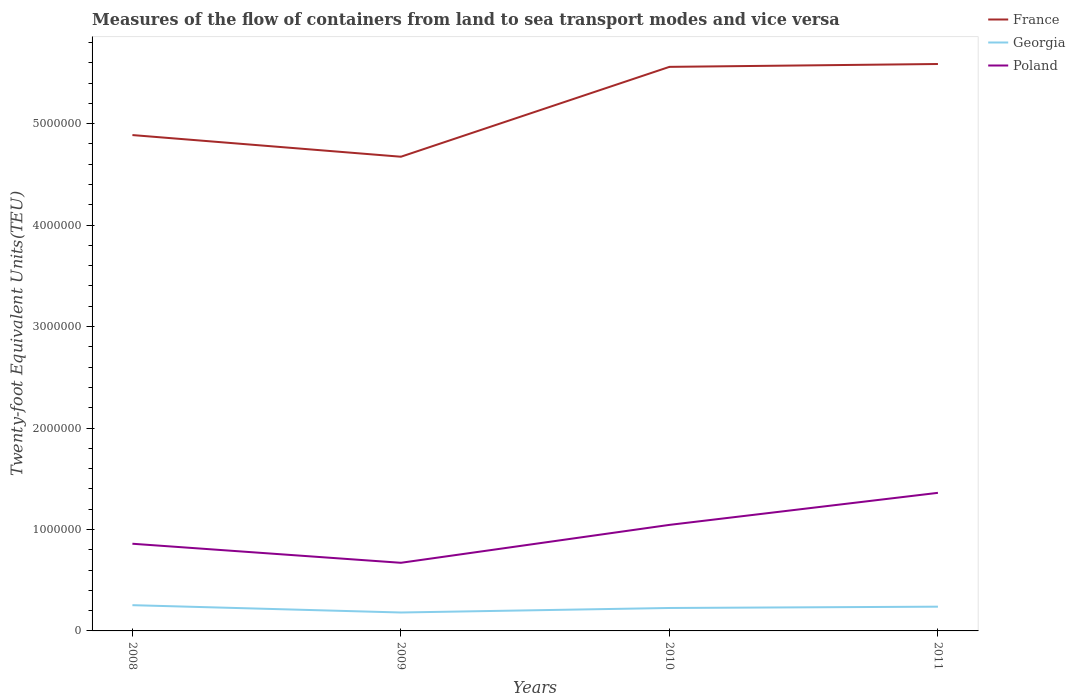How many different coloured lines are there?
Offer a terse response. 3. Does the line corresponding to Georgia intersect with the line corresponding to Poland?
Provide a succinct answer. No. Across all years, what is the maximum container port traffic in France?
Offer a terse response. 4.67e+06. What is the total container port traffic in Georgia in the graph?
Offer a very short reply. -1.29e+04. What is the difference between the highest and the second highest container port traffic in Georgia?
Ensure brevity in your answer.  7.22e+04. What is the difference between the highest and the lowest container port traffic in Georgia?
Your answer should be very brief. 3. Is the container port traffic in France strictly greater than the container port traffic in Poland over the years?
Offer a terse response. No. Does the graph contain grids?
Your response must be concise. No. How are the legend labels stacked?
Provide a succinct answer. Vertical. What is the title of the graph?
Offer a terse response. Measures of the flow of containers from land to sea transport modes and vice versa. Does "Luxembourg" appear as one of the legend labels in the graph?
Offer a terse response. No. What is the label or title of the X-axis?
Give a very brief answer. Years. What is the label or title of the Y-axis?
Your response must be concise. Twenty-foot Equivalent Units(TEU). What is the Twenty-foot Equivalent Units(TEU) of France in 2008?
Provide a succinct answer. 4.89e+06. What is the Twenty-foot Equivalent Units(TEU) of Georgia in 2008?
Provide a succinct answer. 2.54e+05. What is the Twenty-foot Equivalent Units(TEU) in Poland in 2008?
Give a very brief answer. 8.59e+05. What is the Twenty-foot Equivalent Units(TEU) in France in 2009?
Make the answer very short. 4.67e+06. What is the Twenty-foot Equivalent Units(TEU) of Georgia in 2009?
Offer a terse response. 1.82e+05. What is the Twenty-foot Equivalent Units(TEU) in Poland in 2009?
Keep it short and to the point. 6.72e+05. What is the Twenty-foot Equivalent Units(TEU) of France in 2010?
Your answer should be compact. 5.56e+06. What is the Twenty-foot Equivalent Units(TEU) in Georgia in 2010?
Provide a succinct answer. 2.26e+05. What is the Twenty-foot Equivalent Units(TEU) of Poland in 2010?
Offer a terse response. 1.05e+06. What is the Twenty-foot Equivalent Units(TEU) of France in 2011?
Make the answer very short. 5.59e+06. What is the Twenty-foot Equivalent Units(TEU) of Georgia in 2011?
Your answer should be very brief. 2.39e+05. What is the Twenty-foot Equivalent Units(TEU) in Poland in 2011?
Your answer should be very brief. 1.36e+06. Across all years, what is the maximum Twenty-foot Equivalent Units(TEU) of France?
Offer a very short reply. 5.59e+06. Across all years, what is the maximum Twenty-foot Equivalent Units(TEU) of Georgia?
Offer a terse response. 2.54e+05. Across all years, what is the maximum Twenty-foot Equivalent Units(TEU) in Poland?
Offer a very short reply. 1.36e+06. Across all years, what is the minimum Twenty-foot Equivalent Units(TEU) of France?
Provide a succinct answer. 4.67e+06. Across all years, what is the minimum Twenty-foot Equivalent Units(TEU) in Georgia?
Make the answer very short. 1.82e+05. Across all years, what is the minimum Twenty-foot Equivalent Units(TEU) of Poland?
Give a very brief answer. 6.72e+05. What is the total Twenty-foot Equivalent Units(TEU) in France in the graph?
Provide a short and direct response. 2.07e+07. What is the total Twenty-foot Equivalent Units(TEU) of Georgia in the graph?
Provide a succinct answer. 9.01e+05. What is the total Twenty-foot Equivalent Units(TEU) of Poland in the graph?
Offer a very short reply. 3.94e+06. What is the difference between the Twenty-foot Equivalent Units(TEU) of France in 2008 and that in 2009?
Ensure brevity in your answer.  2.14e+05. What is the difference between the Twenty-foot Equivalent Units(TEU) in Georgia in 2008 and that in 2009?
Your answer should be compact. 7.22e+04. What is the difference between the Twenty-foot Equivalent Units(TEU) in Poland in 2008 and that in 2009?
Ensure brevity in your answer.  1.88e+05. What is the difference between the Twenty-foot Equivalent Units(TEU) in France in 2008 and that in 2010?
Ensure brevity in your answer.  -6.72e+05. What is the difference between the Twenty-foot Equivalent Units(TEU) of Georgia in 2008 and that in 2010?
Offer a very short reply. 2.77e+04. What is the difference between the Twenty-foot Equivalent Units(TEU) in Poland in 2008 and that in 2010?
Offer a terse response. -1.86e+05. What is the difference between the Twenty-foot Equivalent Units(TEU) in France in 2008 and that in 2011?
Provide a succinct answer. -7.01e+05. What is the difference between the Twenty-foot Equivalent Units(TEU) of Georgia in 2008 and that in 2011?
Offer a terse response. 1.48e+04. What is the difference between the Twenty-foot Equivalent Units(TEU) of Poland in 2008 and that in 2011?
Make the answer very short. -5.02e+05. What is the difference between the Twenty-foot Equivalent Units(TEU) in France in 2009 and that in 2010?
Give a very brief answer. -8.86e+05. What is the difference between the Twenty-foot Equivalent Units(TEU) of Georgia in 2009 and that in 2010?
Provide a succinct answer. -4.45e+04. What is the difference between the Twenty-foot Equivalent Units(TEU) of Poland in 2009 and that in 2010?
Your answer should be compact. -3.74e+05. What is the difference between the Twenty-foot Equivalent Units(TEU) in France in 2009 and that in 2011?
Give a very brief answer. -9.14e+05. What is the difference between the Twenty-foot Equivalent Units(TEU) of Georgia in 2009 and that in 2011?
Keep it short and to the point. -5.74e+04. What is the difference between the Twenty-foot Equivalent Units(TEU) of Poland in 2009 and that in 2011?
Offer a terse response. -6.90e+05. What is the difference between the Twenty-foot Equivalent Units(TEU) of France in 2010 and that in 2011?
Give a very brief answer. -2.83e+04. What is the difference between the Twenty-foot Equivalent Units(TEU) of Georgia in 2010 and that in 2011?
Offer a terse response. -1.29e+04. What is the difference between the Twenty-foot Equivalent Units(TEU) of Poland in 2010 and that in 2011?
Ensure brevity in your answer.  -3.16e+05. What is the difference between the Twenty-foot Equivalent Units(TEU) in France in 2008 and the Twenty-foot Equivalent Units(TEU) in Georgia in 2009?
Offer a terse response. 4.71e+06. What is the difference between the Twenty-foot Equivalent Units(TEU) of France in 2008 and the Twenty-foot Equivalent Units(TEU) of Poland in 2009?
Provide a short and direct response. 4.22e+06. What is the difference between the Twenty-foot Equivalent Units(TEU) in Georgia in 2008 and the Twenty-foot Equivalent Units(TEU) in Poland in 2009?
Your response must be concise. -4.18e+05. What is the difference between the Twenty-foot Equivalent Units(TEU) of France in 2008 and the Twenty-foot Equivalent Units(TEU) of Georgia in 2010?
Ensure brevity in your answer.  4.66e+06. What is the difference between the Twenty-foot Equivalent Units(TEU) in France in 2008 and the Twenty-foot Equivalent Units(TEU) in Poland in 2010?
Make the answer very short. 3.84e+06. What is the difference between the Twenty-foot Equivalent Units(TEU) of Georgia in 2008 and the Twenty-foot Equivalent Units(TEU) of Poland in 2010?
Provide a short and direct response. -7.91e+05. What is the difference between the Twenty-foot Equivalent Units(TEU) in France in 2008 and the Twenty-foot Equivalent Units(TEU) in Georgia in 2011?
Your answer should be very brief. 4.65e+06. What is the difference between the Twenty-foot Equivalent Units(TEU) in France in 2008 and the Twenty-foot Equivalent Units(TEU) in Poland in 2011?
Your answer should be very brief. 3.53e+06. What is the difference between the Twenty-foot Equivalent Units(TEU) in Georgia in 2008 and the Twenty-foot Equivalent Units(TEU) in Poland in 2011?
Provide a succinct answer. -1.11e+06. What is the difference between the Twenty-foot Equivalent Units(TEU) of France in 2009 and the Twenty-foot Equivalent Units(TEU) of Georgia in 2010?
Your response must be concise. 4.45e+06. What is the difference between the Twenty-foot Equivalent Units(TEU) in France in 2009 and the Twenty-foot Equivalent Units(TEU) in Poland in 2010?
Your answer should be compact. 3.63e+06. What is the difference between the Twenty-foot Equivalent Units(TEU) in Georgia in 2009 and the Twenty-foot Equivalent Units(TEU) in Poland in 2010?
Provide a short and direct response. -8.64e+05. What is the difference between the Twenty-foot Equivalent Units(TEU) of France in 2009 and the Twenty-foot Equivalent Units(TEU) of Georgia in 2011?
Ensure brevity in your answer.  4.44e+06. What is the difference between the Twenty-foot Equivalent Units(TEU) of France in 2009 and the Twenty-foot Equivalent Units(TEU) of Poland in 2011?
Offer a very short reply. 3.31e+06. What is the difference between the Twenty-foot Equivalent Units(TEU) of Georgia in 2009 and the Twenty-foot Equivalent Units(TEU) of Poland in 2011?
Ensure brevity in your answer.  -1.18e+06. What is the difference between the Twenty-foot Equivalent Units(TEU) of France in 2010 and the Twenty-foot Equivalent Units(TEU) of Georgia in 2011?
Ensure brevity in your answer.  5.32e+06. What is the difference between the Twenty-foot Equivalent Units(TEU) in France in 2010 and the Twenty-foot Equivalent Units(TEU) in Poland in 2011?
Ensure brevity in your answer.  4.20e+06. What is the difference between the Twenty-foot Equivalent Units(TEU) of Georgia in 2010 and the Twenty-foot Equivalent Units(TEU) of Poland in 2011?
Your answer should be compact. -1.14e+06. What is the average Twenty-foot Equivalent Units(TEU) in France per year?
Offer a very short reply. 5.18e+06. What is the average Twenty-foot Equivalent Units(TEU) in Georgia per year?
Offer a very short reply. 2.25e+05. What is the average Twenty-foot Equivalent Units(TEU) of Poland per year?
Keep it short and to the point. 9.84e+05. In the year 2008, what is the difference between the Twenty-foot Equivalent Units(TEU) in France and Twenty-foot Equivalent Units(TEU) in Georgia?
Give a very brief answer. 4.63e+06. In the year 2008, what is the difference between the Twenty-foot Equivalent Units(TEU) in France and Twenty-foot Equivalent Units(TEU) in Poland?
Give a very brief answer. 4.03e+06. In the year 2008, what is the difference between the Twenty-foot Equivalent Units(TEU) of Georgia and Twenty-foot Equivalent Units(TEU) of Poland?
Your answer should be very brief. -6.06e+05. In the year 2009, what is the difference between the Twenty-foot Equivalent Units(TEU) in France and Twenty-foot Equivalent Units(TEU) in Georgia?
Ensure brevity in your answer.  4.49e+06. In the year 2009, what is the difference between the Twenty-foot Equivalent Units(TEU) in France and Twenty-foot Equivalent Units(TEU) in Poland?
Your answer should be very brief. 4.00e+06. In the year 2009, what is the difference between the Twenty-foot Equivalent Units(TEU) of Georgia and Twenty-foot Equivalent Units(TEU) of Poland?
Give a very brief answer. -4.90e+05. In the year 2010, what is the difference between the Twenty-foot Equivalent Units(TEU) in France and Twenty-foot Equivalent Units(TEU) in Georgia?
Your answer should be compact. 5.33e+06. In the year 2010, what is the difference between the Twenty-foot Equivalent Units(TEU) in France and Twenty-foot Equivalent Units(TEU) in Poland?
Give a very brief answer. 4.51e+06. In the year 2010, what is the difference between the Twenty-foot Equivalent Units(TEU) of Georgia and Twenty-foot Equivalent Units(TEU) of Poland?
Give a very brief answer. -8.19e+05. In the year 2011, what is the difference between the Twenty-foot Equivalent Units(TEU) in France and Twenty-foot Equivalent Units(TEU) in Georgia?
Provide a short and direct response. 5.35e+06. In the year 2011, what is the difference between the Twenty-foot Equivalent Units(TEU) in France and Twenty-foot Equivalent Units(TEU) in Poland?
Provide a short and direct response. 4.23e+06. In the year 2011, what is the difference between the Twenty-foot Equivalent Units(TEU) in Georgia and Twenty-foot Equivalent Units(TEU) in Poland?
Your answer should be very brief. -1.12e+06. What is the ratio of the Twenty-foot Equivalent Units(TEU) in France in 2008 to that in 2009?
Ensure brevity in your answer.  1.05. What is the ratio of the Twenty-foot Equivalent Units(TEU) in Georgia in 2008 to that in 2009?
Ensure brevity in your answer.  1.4. What is the ratio of the Twenty-foot Equivalent Units(TEU) of Poland in 2008 to that in 2009?
Your answer should be very brief. 1.28. What is the ratio of the Twenty-foot Equivalent Units(TEU) of France in 2008 to that in 2010?
Offer a terse response. 0.88. What is the ratio of the Twenty-foot Equivalent Units(TEU) of Georgia in 2008 to that in 2010?
Offer a terse response. 1.12. What is the ratio of the Twenty-foot Equivalent Units(TEU) of Poland in 2008 to that in 2010?
Keep it short and to the point. 0.82. What is the ratio of the Twenty-foot Equivalent Units(TEU) in France in 2008 to that in 2011?
Give a very brief answer. 0.87. What is the ratio of the Twenty-foot Equivalent Units(TEU) of Georgia in 2008 to that in 2011?
Give a very brief answer. 1.06. What is the ratio of the Twenty-foot Equivalent Units(TEU) of Poland in 2008 to that in 2011?
Provide a succinct answer. 0.63. What is the ratio of the Twenty-foot Equivalent Units(TEU) of France in 2009 to that in 2010?
Your answer should be compact. 0.84. What is the ratio of the Twenty-foot Equivalent Units(TEU) of Georgia in 2009 to that in 2010?
Offer a terse response. 0.8. What is the ratio of the Twenty-foot Equivalent Units(TEU) in Poland in 2009 to that in 2010?
Your response must be concise. 0.64. What is the ratio of the Twenty-foot Equivalent Units(TEU) in France in 2009 to that in 2011?
Your answer should be very brief. 0.84. What is the ratio of the Twenty-foot Equivalent Units(TEU) in Georgia in 2009 to that in 2011?
Ensure brevity in your answer.  0.76. What is the ratio of the Twenty-foot Equivalent Units(TEU) in Poland in 2009 to that in 2011?
Your answer should be compact. 0.49. What is the ratio of the Twenty-foot Equivalent Units(TEU) of Georgia in 2010 to that in 2011?
Ensure brevity in your answer.  0.95. What is the ratio of the Twenty-foot Equivalent Units(TEU) of Poland in 2010 to that in 2011?
Provide a succinct answer. 0.77. What is the difference between the highest and the second highest Twenty-foot Equivalent Units(TEU) in France?
Provide a short and direct response. 2.83e+04. What is the difference between the highest and the second highest Twenty-foot Equivalent Units(TEU) in Georgia?
Your answer should be very brief. 1.48e+04. What is the difference between the highest and the second highest Twenty-foot Equivalent Units(TEU) in Poland?
Make the answer very short. 3.16e+05. What is the difference between the highest and the lowest Twenty-foot Equivalent Units(TEU) of France?
Keep it short and to the point. 9.14e+05. What is the difference between the highest and the lowest Twenty-foot Equivalent Units(TEU) of Georgia?
Ensure brevity in your answer.  7.22e+04. What is the difference between the highest and the lowest Twenty-foot Equivalent Units(TEU) of Poland?
Make the answer very short. 6.90e+05. 